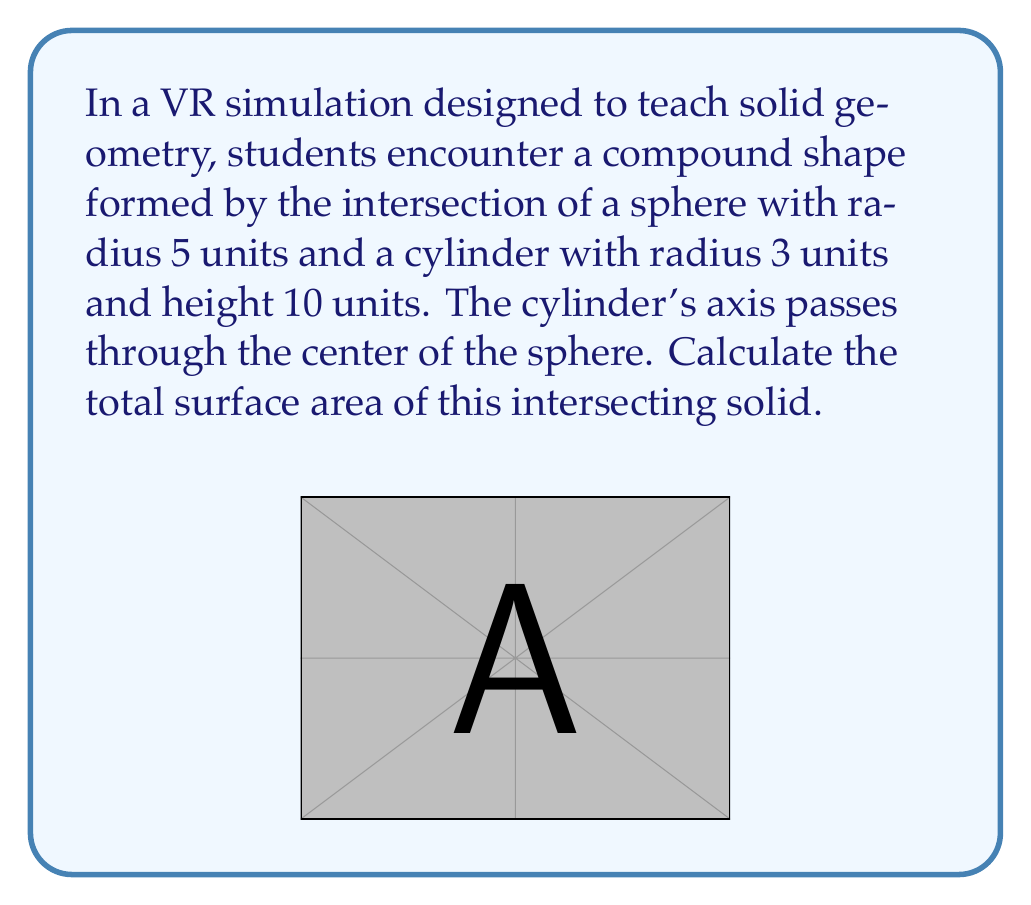Provide a solution to this math problem. Let's approach this step-by-step:

1) The surface area of the intersecting solid consists of three parts:
   a) The curved surface area of the cylinder that's outside the sphere
   b) The surface area of the sphere that's outside the cylinder
   c) The circular areas at the top and bottom of the cylinder

2) Let's first find the height of the spherical cap that's cut off by the cylinder:
   $$h = 5 - \sqrt{5^2 - 3^2} = 5 - 4 = 1$$

3) The curved surface area of the cylinder outside the sphere:
   $$A_{cyl} = 2\pi r (H - 2h) = 2\pi \cdot 3 \cdot (10 - 2) = 48\pi$$

4) The surface area of the sphere outside the cylinder:
   $$A_{sph} = 4\pi R^2 - 2\pi R h = 4\pi \cdot 5^2 - 2\pi \cdot 5 \cdot 1 = 90\pi$$

5) The circular areas at the top and bottom of the cylinder:
   $$A_{circ} = 2\pi r^2 = 2\pi \cdot 3^2 = 18\pi$$

6) The total surface area is the sum of these three parts:
   $$A_{total} = A_{cyl} + A_{sph} + A_{circ} = 48\pi + 90\pi + 18\pi = 156\pi$$

Therefore, the total surface area of the intersecting solid is $156\pi$ square units.
Answer: $156\pi$ square units 